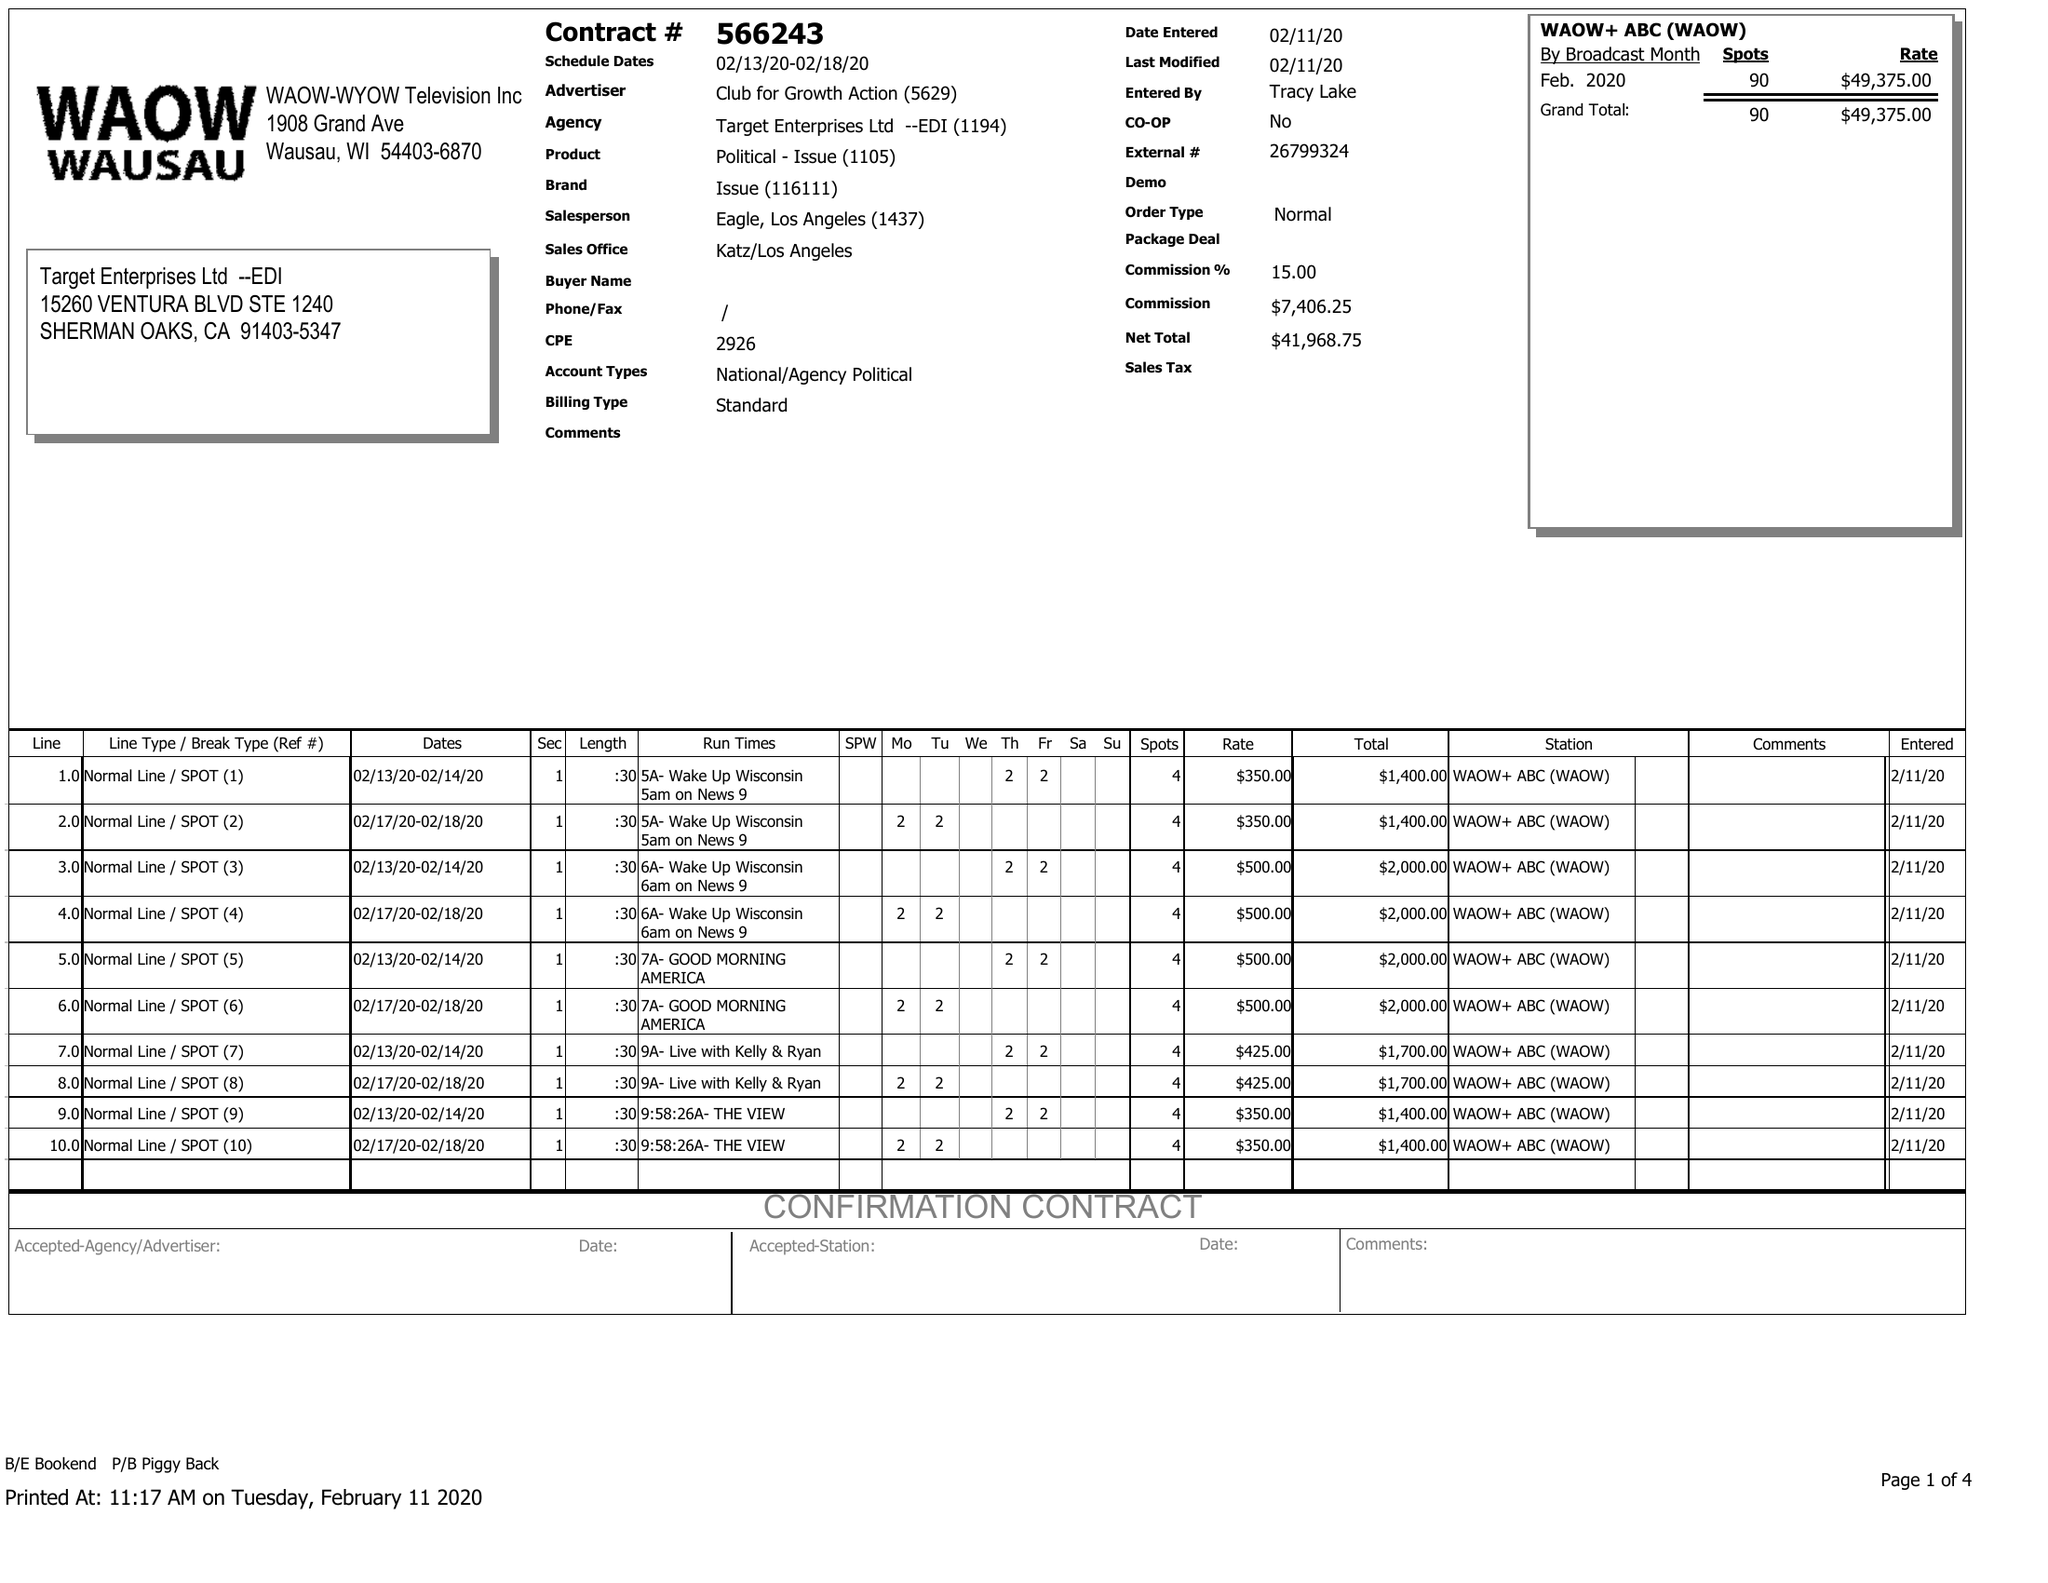What is the value for the flight_to?
Answer the question using a single word or phrase. 02/18/20 